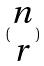<formula> <loc_0><loc_0><loc_500><loc_500>( \begin{matrix} n \\ r \end{matrix} )</formula> 